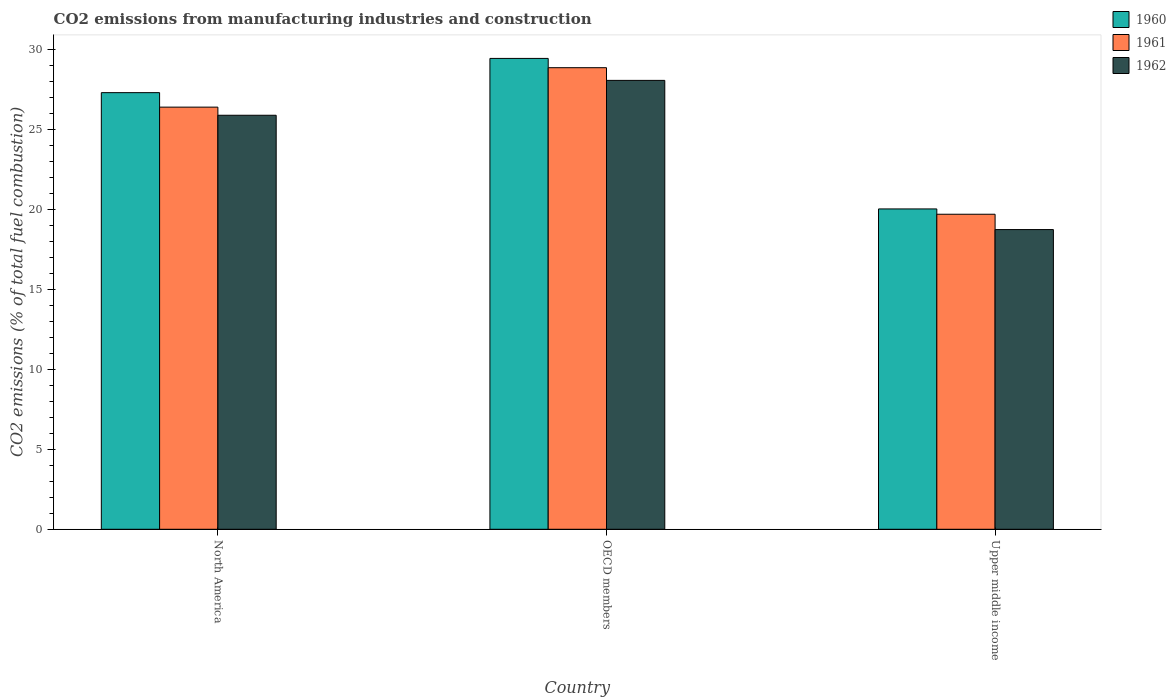How many different coloured bars are there?
Your answer should be compact. 3. How many groups of bars are there?
Your answer should be very brief. 3. Are the number of bars per tick equal to the number of legend labels?
Provide a succinct answer. Yes. Are the number of bars on each tick of the X-axis equal?
Provide a succinct answer. Yes. How many bars are there on the 2nd tick from the left?
Ensure brevity in your answer.  3. How many bars are there on the 3rd tick from the right?
Offer a terse response. 3. What is the amount of CO2 emitted in 1962 in Upper middle income?
Ensure brevity in your answer.  18.76. Across all countries, what is the maximum amount of CO2 emitted in 1961?
Give a very brief answer. 28.89. Across all countries, what is the minimum amount of CO2 emitted in 1961?
Your answer should be very brief. 19.72. In which country was the amount of CO2 emitted in 1960 maximum?
Your answer should be compact. OECD members. In which country was the amount of CO2 emitted in 1960 minimum?
Provide a short and direct response. Upper middle income. What is the total amount of CO2 emitted in 1960 in the graph?
Offer a very short reply. 76.84. What is the difference between the amount of CO2 emitted in 1962 in North America and that in OECD members?
Offer a terse response. -2.18. What is the difference between the amount of CO2 emitted in 1962 in Upper middle income and the amount of CO2 emitted in 1961 in North America?
Ensure brevity in your answer.  -7.66. What is the average amount of CO2 emitted in 1961 per country?
Offer a very short reply. 25.01. What is the difference between the amount of CO2 emitted of/in 1961 and amount of CO2 emitted of/in 1960 in North America?
Ensure brevity in your answer.  -0.91. In how many countries, is the amount of CO2 emitted in 1961 greater than 10 %?
Provide a short and direct response. 3. What is the ratio of the amount of CO2 emitted in 1961 in North America to that in Upper middle income?
Provide a succinct answer. 1.34. Is the difference between the amount of CO2 emitted in 1961 in North America and OECD members greater than the difference between the amount of CO2 emitted in 1960 in North America and OECD members?
Offer a terse response. No. What is the difference between the highest and the second highest amount of CO2 emitted in 1960?
Your response must be concise. 7.28. What is the difference between the highest and the lowest amount of CO2 emitted in 1961?
Make the answer very short. 9.17. What does the 1st bar from the right in North America represents?
Keep it short and to the point. 1962. Are all the bars in the graph horizontal?
Ensure brevity in your answer.  No. What is the difference between two consecutive major ticks on the Y-axis?
Your answer should be compact. 5. Are the values on the major ticks of Y-axis written in scientific E-notation?
Offer a very short reply. No. Does the graph contain any zero values?
Make the answer very short. No. Does the graph contain grids?
Keep it short and to the point. No. Where does the legend appear in the graph?
Offer a very short reply. Top right. How are the legend labels stacked?
Your response must be concise. Vertical. What is the title of the graph?
Give a very brief answer. CO2 emissions from manufacturing industries and construction. Does "1991" appear as one of the legend labels in the graph?
Offer a terse response. No. What is the label or title of the Y-axis?
Make the answer very short. CO2 emissions (% of total fuel combustion). What is the CO2 emissions (% of total fuel combustion) in 1960 in North America?
Your answer should be compact. 27.33. What is the CO2 emissions (% of total fuel combustion) in 1961 in North America?
Give a very brief answer. 26.42. What is the CO2 emissions (% of total fuel combustion) in 1962 in North America?
Give a very brief answer. 25.91. What is the CO2 emissions (% of total fuel combustion) of 1960 in OECD members?
Keep it short and to the point. 29.47. What is the CO2 emissions (% of total fuel combustion) in 1961 in OECD members?
Offer a terse response. 28.89. What is the CO2 emissions (% of total fuel combustion) of 1962 in OECD members?
Offer a terse response. 28.09. What is the CO2 emissions (% of total fuel combustion) of 1960 in Upper middle income?
Give a very brief answer. 20.05. What is the CO2 emissions (% of total fuel combustion) in 1961 in Upper middle income?
Give a very brief answer. 19.72. What is the CO2 emissions (% of total fuel combustion) in 1962 in Upper middle income?
Offer a terse response. 18.76. Across all countries, what is the maximum CO2 emissions (% of total fuel combustion) of 1960?
Offer a terse response. 29.47. Across all countries, what is the maximum CO2 emissions (% of total fuel combustion) in 1961?
Give a very brief answer. 28.89. Across all countries, what is the maximum CO2 emissions (% of total fuel combustion) of 1962?
Provide a short and direct response. 28.09. Across all countries, what is the minimum CO2 emissions (% of total fuel combustion) of 1960?
Ensure brevity in your answer.  20.05. Across all countries, what is the minimum CO2 emissions (% of total fuel combustion) of 1961?
Keep it short and to the point. 19.72. Across all countries, what is the minimum CO2 emissions (% of total fuel combustion) in 1962?
Give a very brief answer. 18.76. What is the total CO2 emissions (% of total fuel combustion) of 1960 in the graph?
Your answer should be compact. 76.84. What is the total CO2 emissions (% of total fuel combustion) in 1961 in the graph?
Give a very brief answer. 75.02. What is the total CO2 emissions (% of total fuel combustion) in 1962 in the graph?
Make the answer very short. 72.76. What is the difference between the CO2 emissions (% of total fuel combustion) of 1960 in North America and that in OECD members?
Offer a very short reply. -2.14. What is the difference between the CO2 emissions (% of total fuel combustion) of 1961 in North America and that in OECD members?
Your answer should be compact. -2.47. What is the difference between the CO2 emissions (% of total fuel combustion) in 1962 in North America and that in OECD members?
Provide a short and direct response. -2.18. What is the difference between the CO2 emissions (% of total fuel combustion) of 1960 in North America and that in Upper middle income?
Offer a terse response. 7.28. What is the difference between the CO2 emissions (% of total fuel combustion) in 1961 in North America and that in Upper middle income?
Offer a very short reply. 6.7. What is the difference between the CO2 emissions (% of total fuel combustion) of 1962 in North America and that in Upper middle income?
Your answer should be compact. 7.15. What is the difference between the CO2 emissions (% of total fuel combustion) in 1960 in OECD members and that in Upper middle income?
Make the answer very short. 9.42. What is the difference between the CO2 emissions (% of total fuel combustion) of 1961 in OECD members and that in Upper middle income?
Offer a terse response. 9.17. What is the difference between the CO2 emissions (% of total fuel combustion) of 1962 in OECD members and that in Upper middle income?
Keep it short and to the point. 9.34. What is the difference between the CO2 emissions (% of total fuel combustion) of 1960 in North America and the CO2 emissions (% of total fuel combustion) of 1961 in OECD members?
Make the answer very short. -1.56. What is the difference between the CO2 emissions (% of total fuel combustion) of 1960 in North America and the CO2 emissions (% of total fuel combustion) of 1962 in OECD members?
Make the answer very short. -0.77. What is the difference between the CO2 emissions (% of total fuel combustion) of 1961 in North America and the CO2 emissions (% of total fuel combustion) of 1962 in OECD members?
Offer a very short reply. -1.67. What is the difference between the CO2 emissions (% of total fuel combustion) of 1960 in North America and the CO2 emissions (% of total fuel combustion) of 1961 in Upper middle income?
Provide a short and direct response. 7.61. What is the difference between the CO2 emissions (% of total fuel combustion) of 1960 in North America and the CO2 emissions (% of total fuel combustion) of 1962 in Upper middle income?
Your answer should be compact. 8.57. What is the difference between the CO2 emissions (% of total fuel combustion) of 1961 in North America and the CO2 emissions (% of total fuel combustion) of 1962 in Upper middle income?
Provide a succinct answer. 7.66. What is the difference between the CO2 emissions (% of total fuel combustion) of 1960 in OECD members and the CO2 emissions (% of total fuel combustion) of 1961 in Upper middle income?
Provide a short and direct response. 9.75. What is the difference between the CO2 emissions (% of total fuel combustion) in 1960 in OECD members and the CO2 emissions (% of total fuel combustion) in 1962 in Upper middle income?
Make the answer very short. 10.71. What is the difference between the CO2 emissions (% of total fuel combustion) in 1961 in OECD members and the CO2 emissions (% of total fuel combustion) in 1962 in Upper middle income?
Give a very brief answer. 10.13. What is the average CO2 emissions (% of total fuel combustion) in 1960 per country?
Keep it short and to the point. 25.61. What is the average CO2 emissions (% of total fuel combustion) in 1961 per country?
Offer a very short reply. 25.01. What is the average CO2 emissions (% of total fuel combustion) in 1962 per country?
Ensure brevity in your answer.  24.25. What is the difference between the CO2 emissions (% of total fuel combustion) of 1960 and CO2 emissions (% of total fuel combustion) of 1961 in North America?
Your answer should be compact. 0.91. What is the difference between the CO2 emissions (% of total fuel combustion) of 1960 and CO2 emissions (% of total fuel combustion) of 1962 in North America?
Offer a very short reply. 1.42. What is the difference between the CO2 emissions (% of total fuel combustion) in 1961 and CO2 emissions (% of total fuel combustion) in 1962 in North America?
Offer a very short reply. 0.51. What is the difference between the CO2 emissions (% of total fuel combustion) of 1960 and CO2 emissions (% of total fuel combustion) of 1961 in OECD members?
Your answer should be compact. 0.58. What is the difference between the CO2 emissions (% of total fuel combustion) of 1960 and CO2 emissions (% of total fuel combustion) of 1962 in OECD members?
Offer a terse response. 1.38. What is the difference between the CO2 emissions (% of total fuel combustion) in 1961 and CO2 emissions (% of total fuel combustion) in 1962 in OECD members?
Your answer should be very brief. 0.79. What is the difference between the CO2 emissions (% of total fuel combustion) in 1960 and CO2 emissions (% of total fuel combustion) in 1961 in Upper middle income?
Your answer should be very brief. 0.33. What is the difference between the CO2 emissions (% of total fuel combustion) of 1960 and CO2 emissions (% of total fuel combustion) of 1962 in Upper middle income?
Your answer should be compact. 1.29. What is the difference between the CO2 emissions (% of total fuel combustion) in 1961 and CO2 emissions (% of total fuel combustion) in 1962 in Upper middle income?
Your answer should be very brief. 0.96. What is the ratio of the CO2 emissions (% of total fuel combustion) of 1960 in North America to that in OECD members?
Provide a succinct answer. 0.93. What is the ratio of the CO2 emissions (% of total fuel combustion) in 1961 in North America to that in OECD members?
Keep it short and to the point. 0.91. What is the ratio of the CO2 emissions (% of total fuel combustion) in 1962 in North America to that in OECD members?
Your answer should be compact. 0.92. What is the ratio of the CO2 emissions (% of total fuel combustion) in 1960 in North America to that in Upper middle income?
Provide a succinct answer. 1.36. What is the ratio of the CO2 emissions (% of total fuel combustion) of 1961 in North America to that in Upper middle income?
Give a very brief answer. 1.34. What is the ratio of the CO2 emissions (% of total fuel combustion) of 1962 in North America to that in Upper middle income?
Offer a very short reply. 1.38. What is the ratio of the CO2 emissions (% of total fuel combustion) of 1960 in OECD members to that in Upper middle income?
Ensure brevity in your answer.  1.47. What is the ratio of the CO2 emissions (% of total fuel combustion) of 1961 in OECD members to that in Upper middle income?
Give a very brief answer. 1.47. What is the ratio of the CO2 emissions (% of total fuel combustion) of 1962 in OECD members to that in Upper middle income?
Ensure brevity in your answer.  1.5. What is the difference between the highest and the second highest CO2 emissions (% of total fuel combustion) of 1960?
Give a very brief answer. 2.14. What is the difference between the highest and the second highest CO2 emissions (% of total fuel combustion) of 1961?
Offer a terse response. 2.47. What is the difference between the highest and the second highest CO2 emissions (% of total fuel combustion) in 1962?
Provide a succinct answer. 2.18. What is the difference between the highest and the lowest CO2 emissions (% of total fuel combustion) in 1960?
Keep it short and to the point. 9.42. What is the difference between the highest and the lowest CO2 emissions (% of total fuel combustion) in 1961?
Provide a short and direct response. 9.17. What is the difference between the highest and the lowest CO2 emissions (% of total fuel combustion) of 1962?
Offer a terse response. 9.34. 